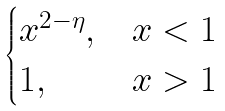<formula> <loc_0><loc_0><loc_500><loc_500>\begin{cases} x ^ { 2 - \eta } , & x < 1 \\ 1 , & x > 1 \end{cases}</formula> 